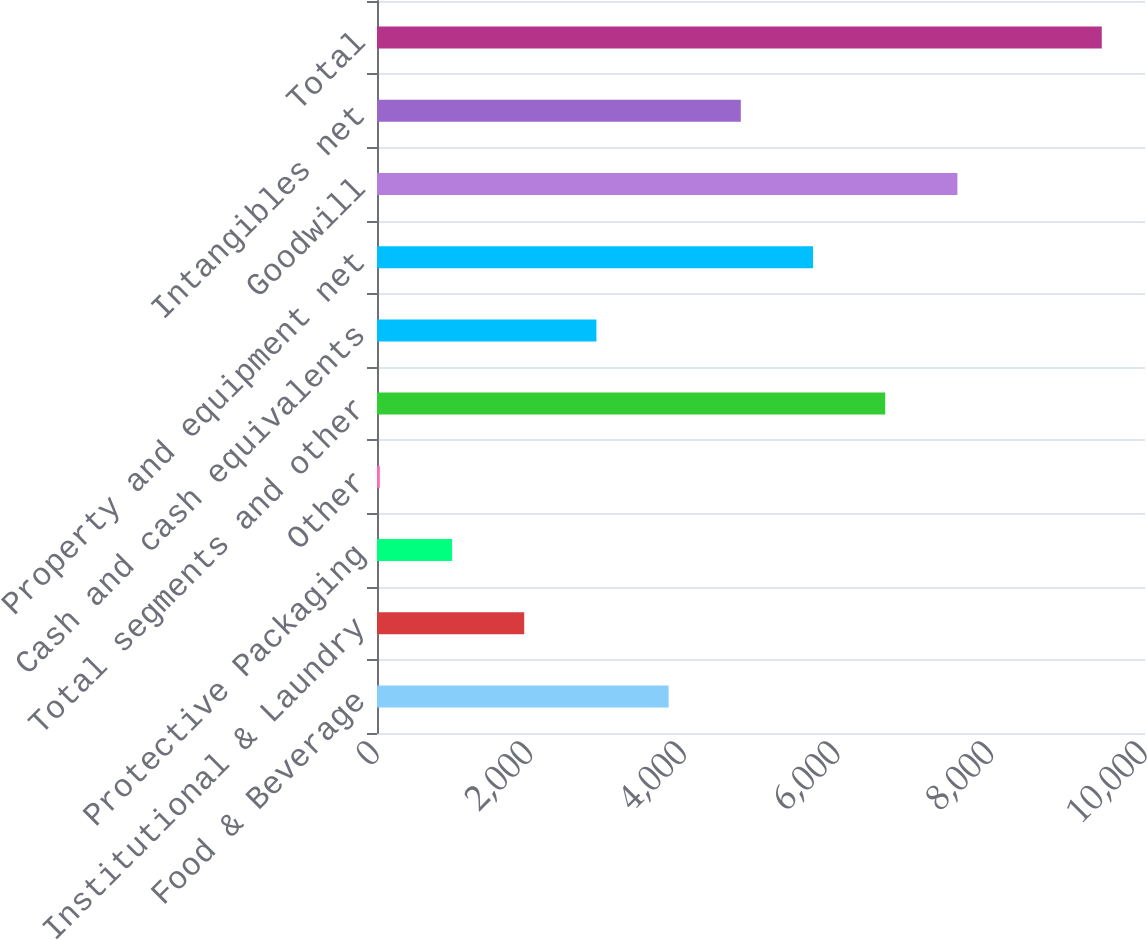Convert chart. <chart><loc_0><loc_0><loc_500><loc_500><bar_chart><fcel>Food & Beverage<fcel>Institutional & Laundry<fcel>Protective Packaging<fcel>Other<fcel>Total segments and other<fcel>Cash and cash equivalents<fcel>Property and equipment net<fcel>Goodwill<fcel>Intangibles net<fcel>Total<nl><fcel>3797.08<fcel>1917.04<fcel>977.02<fcel>37<fcel>6617.14<fcel>2857.06<fcel>5677.12<fcel>7557.16<fcel>4737.1<fcel>9437.2<nl></chart> 